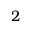Convert formula to latex. <formula><loc_0><loc_0><loc_500><loc_500>2</formula> 